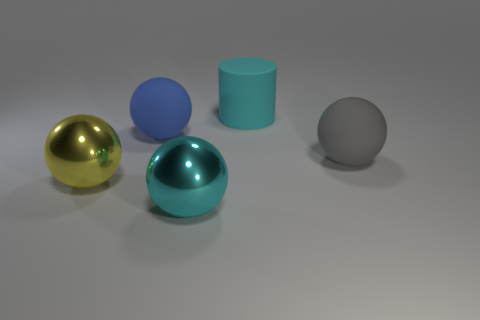What shape is the yellow metallic object?
Your answer should be very brief. Sphere. There is a cyan thing that is the same shape as the blue object; what size is it?
Give a very brief answer. Large. Is there any other thing that is made of the same material as the big blue sphere?
Your answer should be very brief. Yes. There is a cyan object that is behind the large metal object on the left side of the large blue sphere; what is its size?
Your response must be concise. Large. Are there the same number of yellow metallic spheres on the right side of the big cyan shiny ball and cylinders?
Keep it short and to the point. No. How many other things are there of the same color as the cylinder?
Offer a terse response. 1. Are there fewer blue rubber objects that are on the left side of the cyan cylinder than big cyan objects?
Provide a succinct answer. Yes. Is there a yellow object of the same size as the yellow sphere?
Provide a short and direct response. No. There is a big rubber cylinder; is its color the same as the large matte ball behind the gray object?
Offer a terse response. No. What number of large cyan metal spheres are right of the big matte sphere left of the large cyan shiny ball?
Keep it short and to the point. 1. 